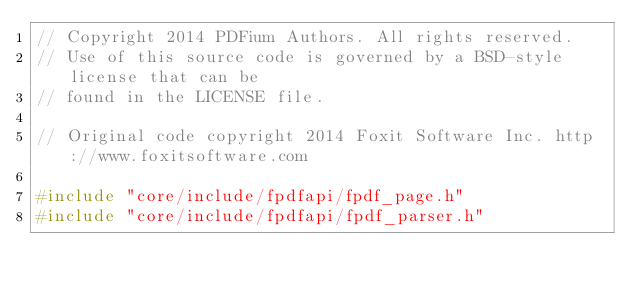Convert code to text. <code><loc_0><loc_0><loc_500><loc_500><_C++_>// Copyright 2014 PDFium Authors. All rights reserved.
// Use of this source code is governed by a BSD-style license that can be
// found in the LICENSE file.

// Original code copyright 2014 Foxit Software Inc. http://www.foxitsoftware.com

#include "core/include/fpdfapi/fpdf_page.h"
#include "core/include/fpdfapi/fpdf_parser.h"</code> 